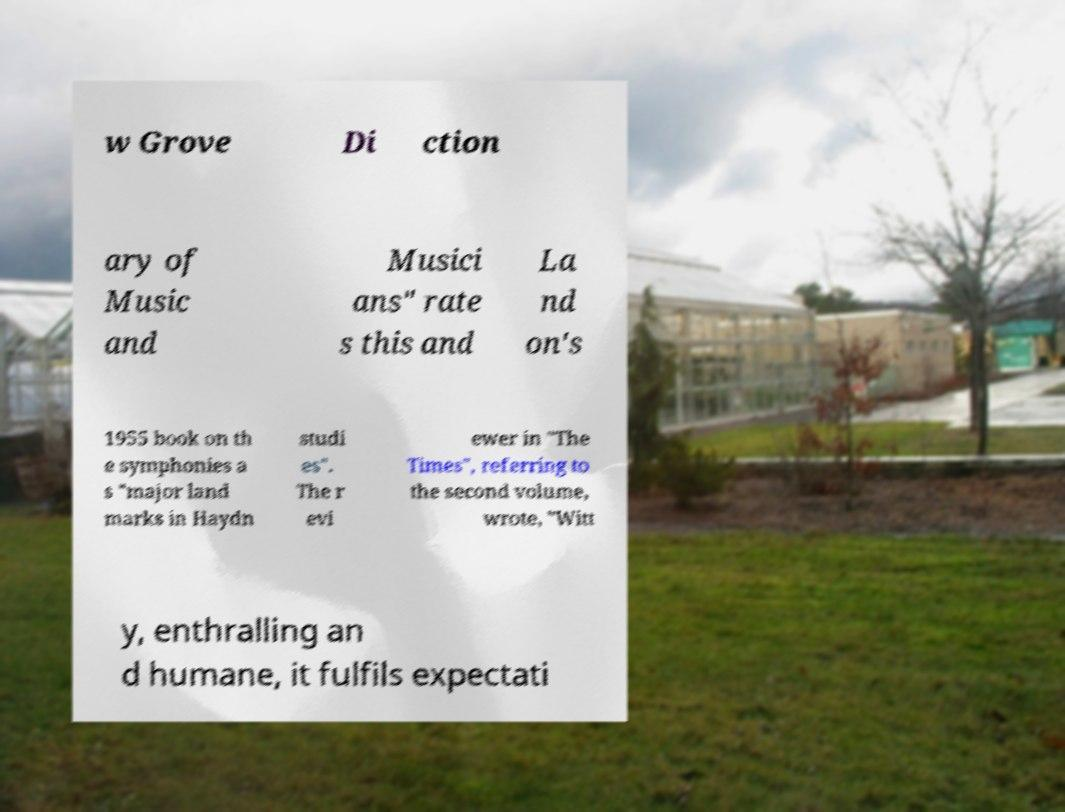Could you assist in decoding the text presented in this image and type it out clearly? w Grove Di ction ary of Music and Musici ans" rate s this and La nd on's 1955 book on th e symphonies a s "major land marks in Haydn studi es". The r evi ewer in "The Times", referring to the second volume, wrote, "Witt y, enthralling an d humane, it fulfils expectati 